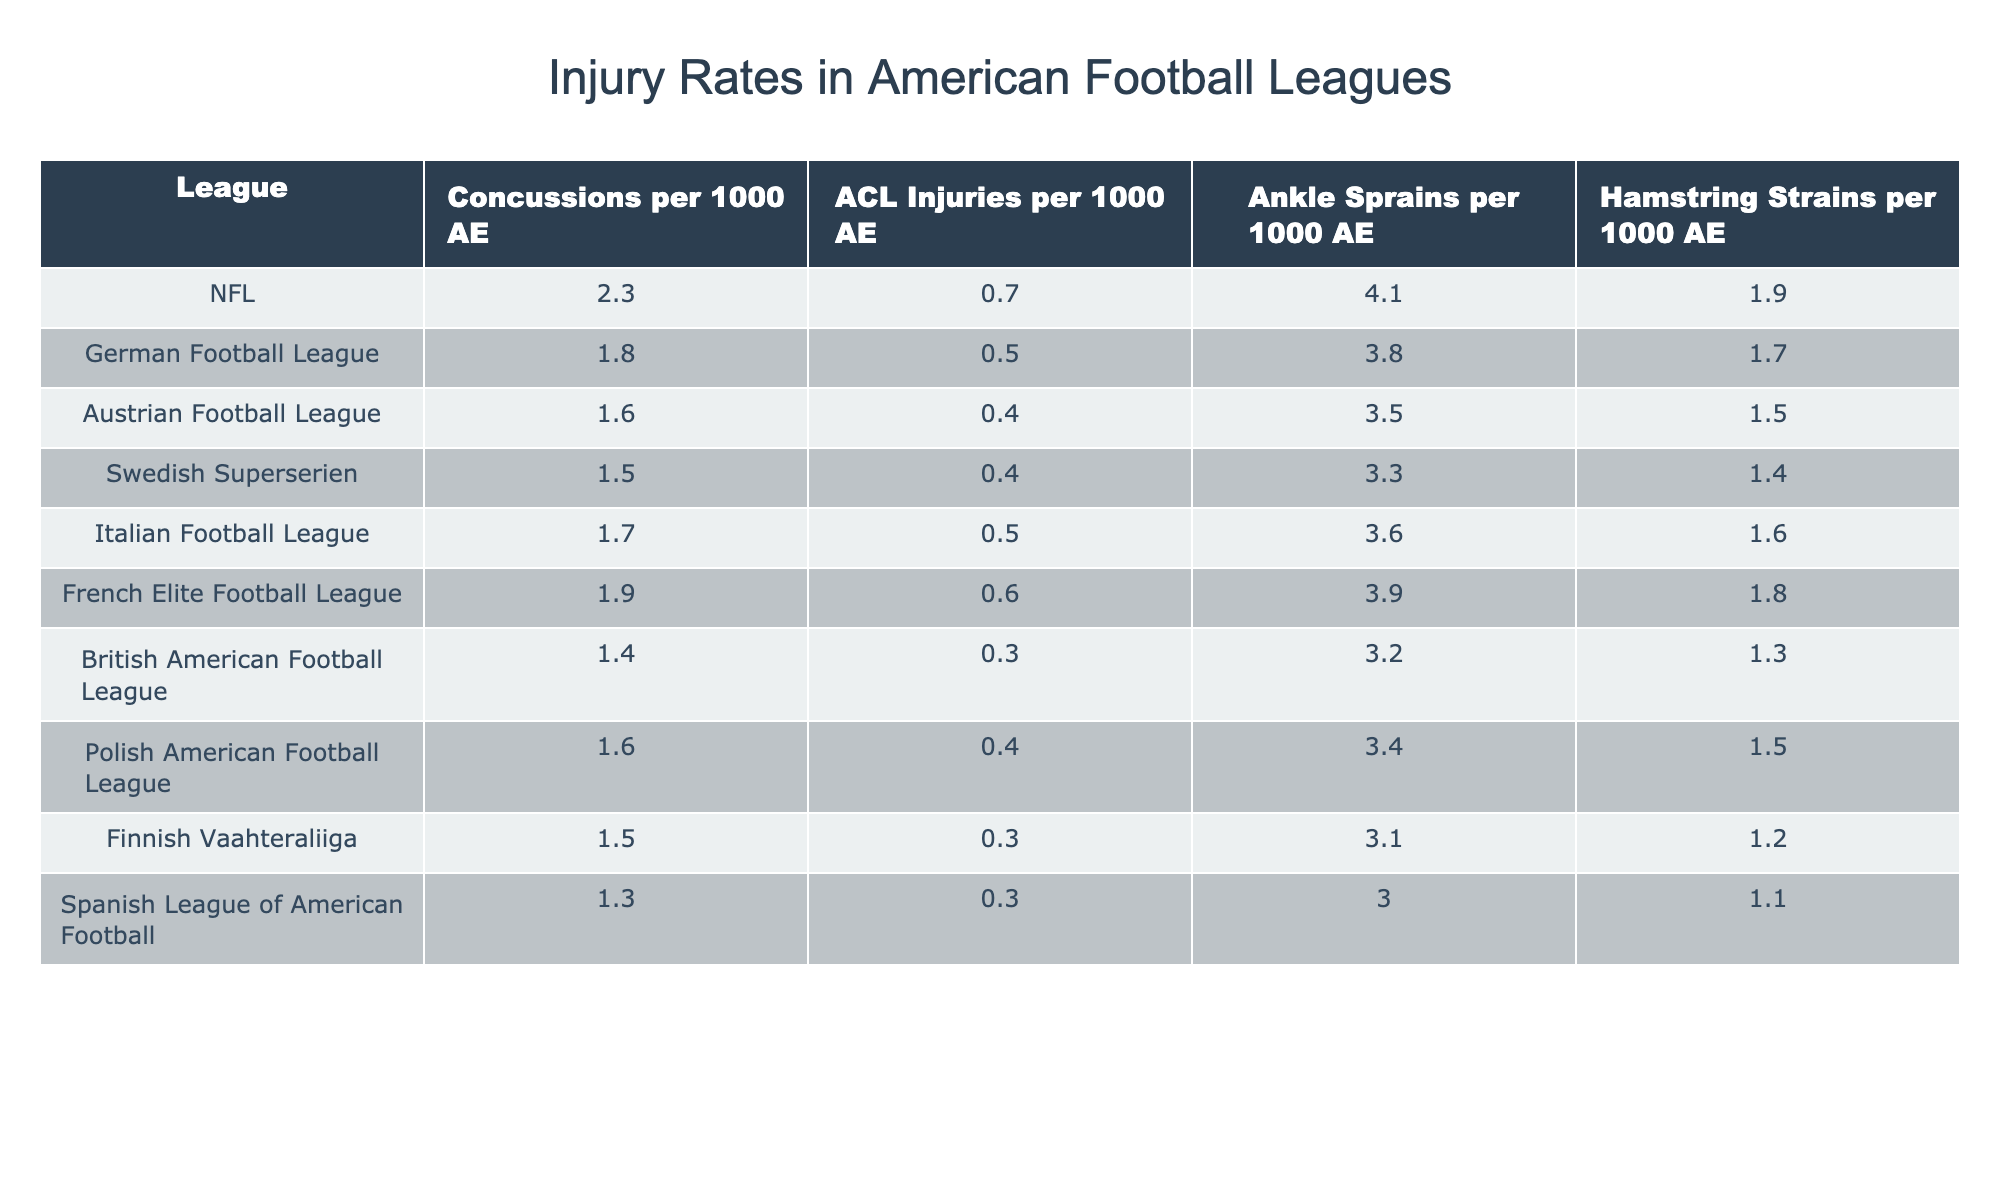What's the highest rate of concussions per 1000 athletic exposures in the table? Looking at the column for concussions per 1000 athletic exposures, the NFL has the highest rate at 2.3.
Answer: 2.3 Which league has the lowest rate of ACL injuries per 1000 athletic exposures? In the ACL injuries column, the British American Football League has the lowest rate at 0.3.
Answer: 0.3 What is the difference in ankle sprains per 1000 AE between the NFL and the Austrian Football League? The NFL has 4.1 ankle sprains per 1000 AE, while the Austrian Football League has 3.5. The difference is calculated as 4.1 - 3.5 = 0.6.
Answer: 0.6 What is the average rate of hamstring strains across all listed leagues? To find the average, sum the values for hamstring strains (1.9 + 1.7 + 1.5 + 1.4 + 1.6 + 1.8 + 1.3 + 1.5 + 1.2 + 1.1 = 15.6) and divide by the number of leagues (10). So, 15.6 / 10 = 1.56.
Answer: 1.56 Was the rate of concussions higher in the NFL compared to the Swedish Superserien? The NFL has a concussion rate of 2.3, while the Swedish Superserien has a rate of 1.5. Since 2.3 is greater than 1.5, the statement is true.
Answer: Yes Which league has the second highest rate of ankle sprains? Looking at the ankle sprains column, the NFL has the highest at 4.1, and the next is the German Football League at 3.8.
Answer: German Football League If we combine the concussion and ACL injury rates for the Polish American Football League, what is the total? The Polish American Football League has 1.6 concussions and 0.4 ACL injuries. Adding these together gives 1.6 + 0.4 = 2.0.
Answer: 2.0 Is the rate of hamstring strains in the French Elite Football League above average according to the table? The French Elite Football League has a hamstring strain rate of 1.8. The average rate, calculated previously, is 1.56. Since 1.8 is greater than 1.56, the statement is true.
Answer: Yes What is the total rate of ankle sprains among all leagues in the table? Summing the ankle sprain values from all leagues gives (4.1 + 3.8 + 3.5 + 3.3 + 3.6 + 3.9 + 3.2 + 3.4 + 3.1 + 3.0 = 33.8).
Answer: 33.8 In which league is the rate of ACL injuries closest to the NFL’s rate of 0.7? The Italian Football League has an ACL injury rate of 0.5, which is the closest to the NFL's rate (0.7).
Answer: Italian Football League 